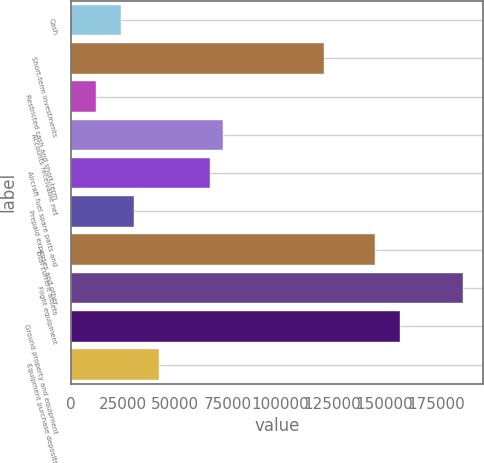<chart> <loc_0><loc_0><loc_500><loc_500><bar_chart><fcel>Cash<fcel>Short-term investments<fcel>Restricted cash and short-term<fcel>Accounts receivable net<fcel>Aircraft fuel spare parts and<fcel>Prepaid expenses and other<fcel>Total current assets<fcel>Flight equipment<fcel>Ground property and equipment<fcel>Equipment purchase deposits<nl><fcel>24235<fcel>121155<fcel>12120<fcel>72695<fcel>66637.5<fcel>30292.5<fcel>145385<fcel>187788<fcel>157500<fcel>42407.5<nl></chart> 